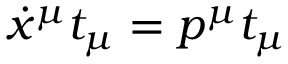<formula> <loc_0><loc_0><loc_500><loc_500>\dot { x } ^ { \mu } t _ { \mu } = p ^ { \mu } t _ { \mu }</formula> 